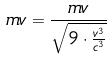<formula> <loc_0><loc_0><loc_500><loc_500>m v = \frac { m v } { \sqrt { 9 \cdot \frac { v ^ { 3 } } { c ^ { 3 } } } }</formula> 